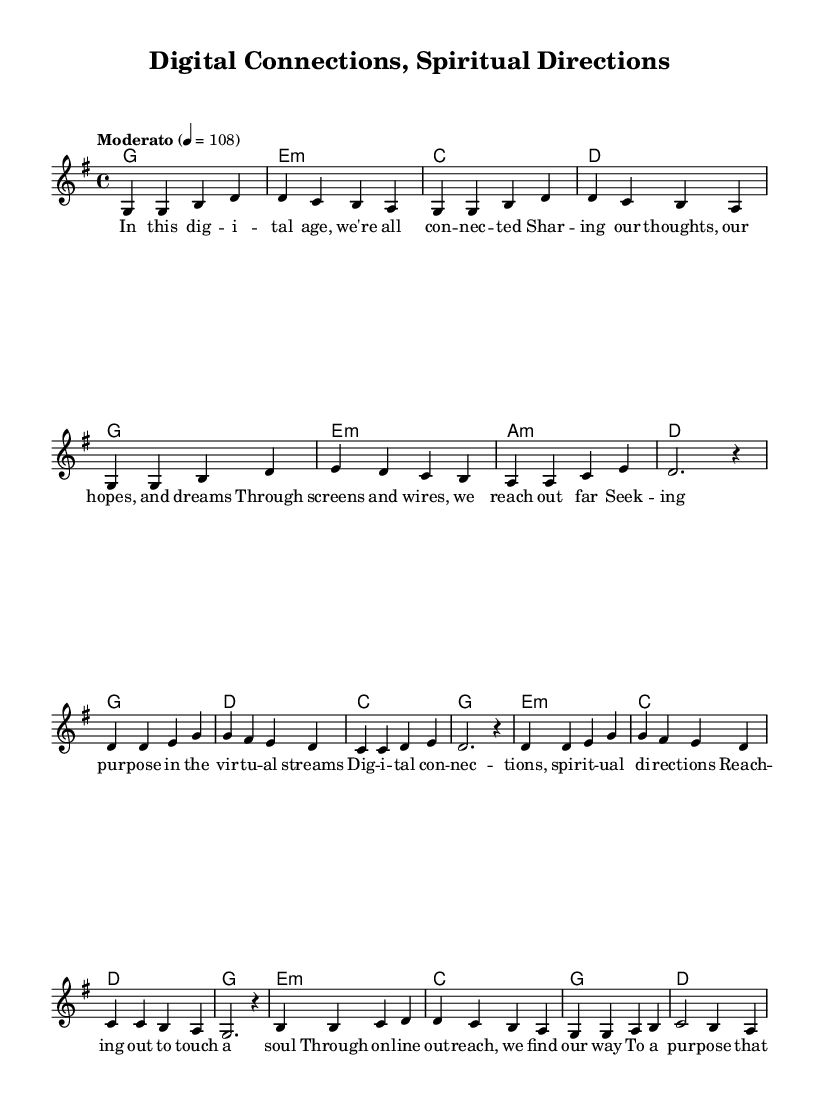What is the key signature of this music? The key signature is indicated at the beginning of the score, showing one sharp. This corresponds to the G major scale, which has an F# as its sharp note.
Answer: G major What is the time signature of this piece? The time signature is located at the start of the music and indicates how many beats are in each measure. Here, it shows a 4 over 4, meaning there are four beats per measure.
Answer: 4/4 What is the tempo marking of this music? The tempo is written in the score and provides the speed of the music. The marking here specifies "Moderato" with a specific metronome marking of 108 beats per minute.
Answer: Moderato, 108 How many measures are in the verse section? To determine this, count the measures that are specifically dedicated to the verse in the score. The verse is structured with a total of eight measures.
Answer: 8 What is the chord progression in the chorus? The chord progression is a series of chords that accompany the melody during the chorus. By observing the harmonies section, the progression is: G, D, C, G, E minor, C, D, G.
Answer: G, D, C, G, E minor, C, D, G What is the primary theme reflected in the lyrics? Analyzing the lyrics reveals a focus on connectivity and finding spiritual purpose through digital means. The verses portray the theme of seeking purpose in online outreach, directly addressing the idea of interconnectedness in a spiritual sense.
Answer: Connectivity and spiritual purpose What is the mood or emotion conveyed by the bridge lyrics? The bridge lyrics convey a sense of belonging and destiny through networked humanity. The words used indicate a shared experience among people seeking their place and purpose, encapsulating hope and unity.
Answer: Belonging and unity 